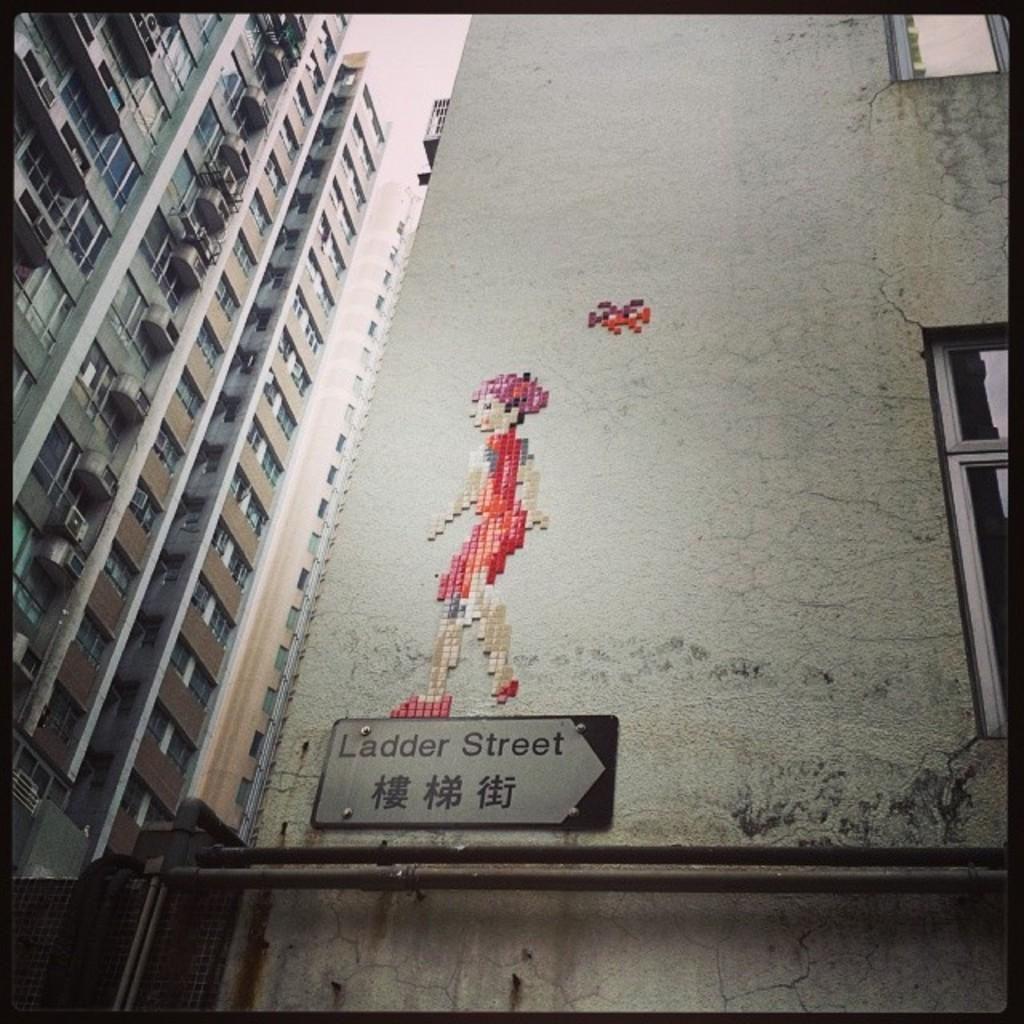In one or two sentences, can you explain what this image depicts? In this image we can see few buildings, there are few pipes, a board and a picture to the building and the sky in the background. 